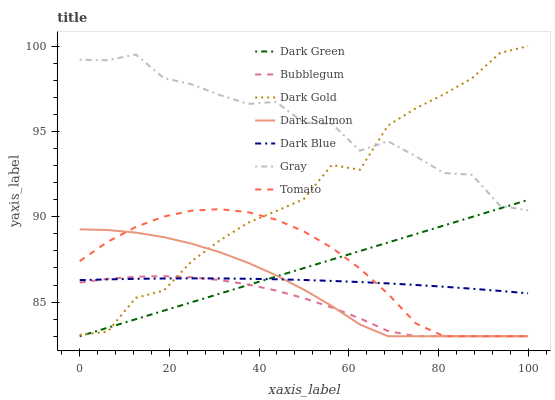Does Bubblegum have the minimum area under the curve?
Answer yes or no. Yes. Does Gray have the maximum area under the curve?
Answer yes or no. Yes. Does Dark Gold have the minimum area under the curve?
Answer yes or no. No. Does Dark Gold have the maximum area under the curve?
Answer yes or no. No. Is Dark Green the smoothest?
Answer yes or no. Yes. Is Gray the roughest?
Answer yes or no. Yes. Is Dark Gold the smoothest?
Answer yes or no. No. Is Dark Gold the roughest?
Answer yes or no. No. Does Tomato have the lowest value?
Answer yes or no. Yes. Does Dark Gold have the lowest value?
Answer yes or no. No. Does Dark Gold have the highest value?
Answer yes or no. Yes. Does Gray have the highest value?
Answer yes or no. No. Is Dark Salmon less than Gray?
Answer yes or no. Yes. Is Gray greater than Dark Blue?
Answer yes or no. Yes. Does Dark Salmon intersect Dark Gold?
Answer yes or no. Yes. Is Dark Salmon less than Dark Gold?
Answer yes or no. No. Is Dark Salmon greater than Dark Gold?
Answer yes or no. No. Does Dark Salmon intersect Gray?
Answer yes or no. No. 